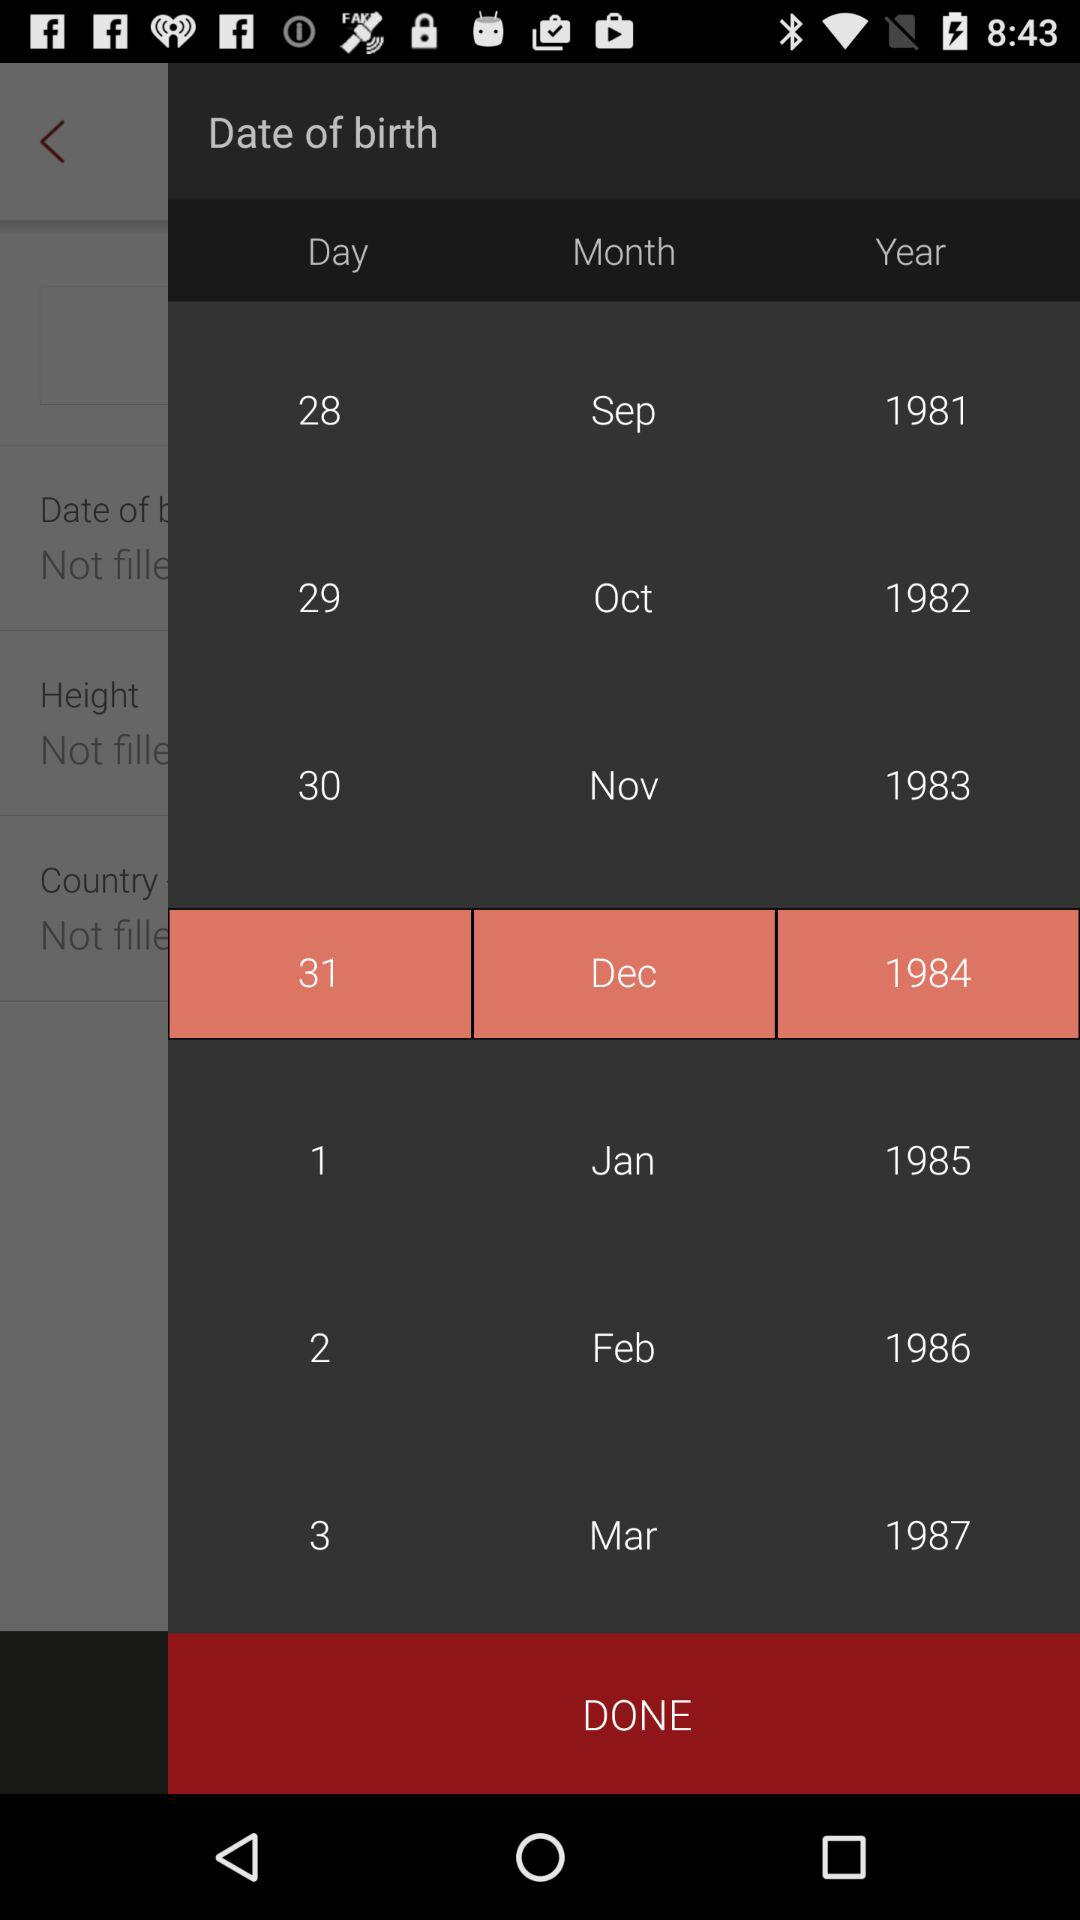What date is selected on the screen? The selected date is December 31, 1984. 